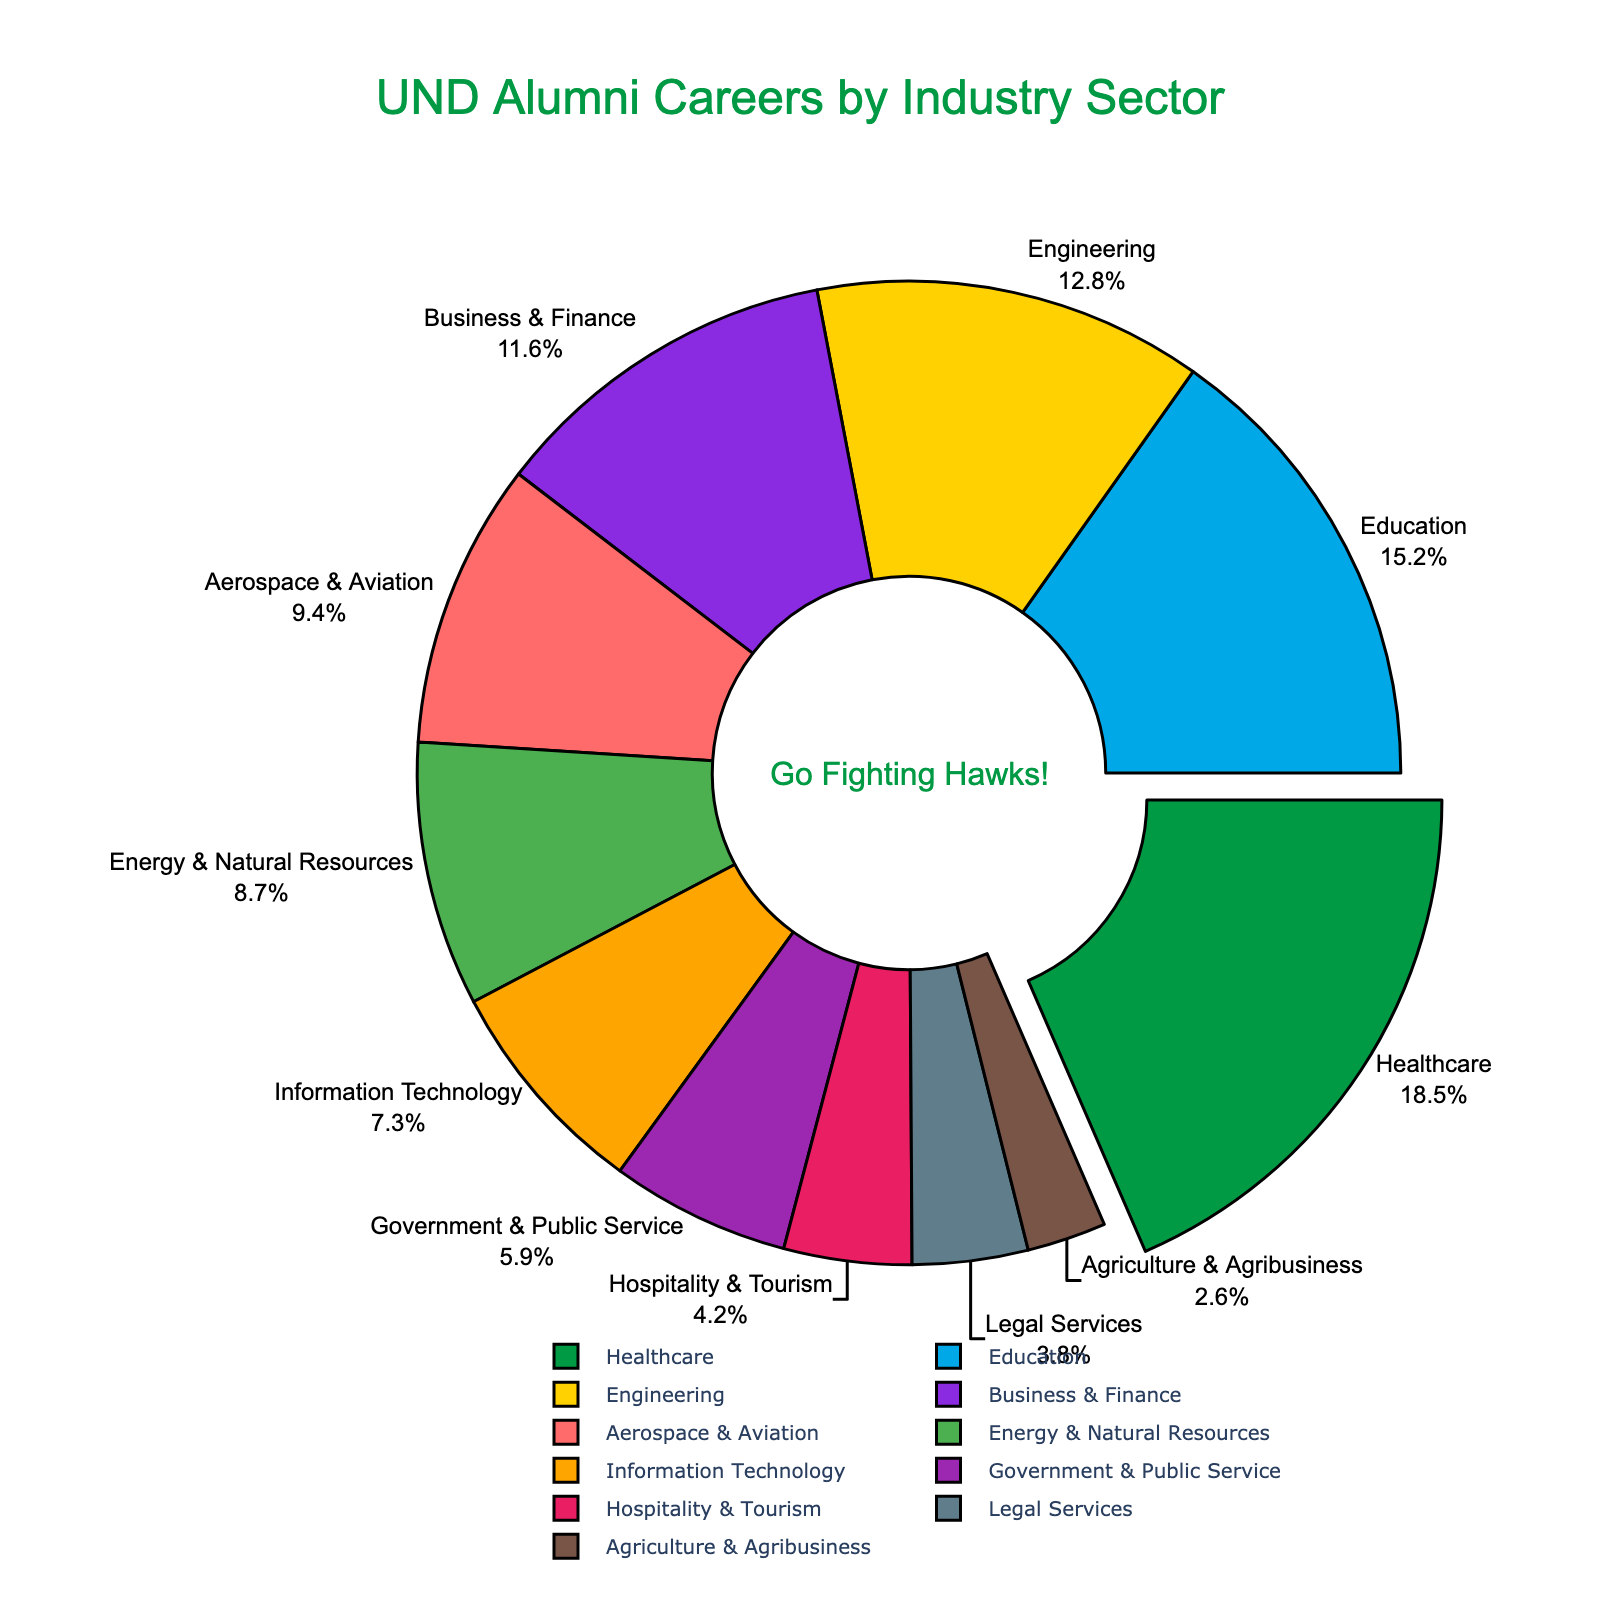What percentage of UND alumni work in the Healthcare sector? The pie chart labels indicate the percentage for each sector. The label for Healthcare shows 18.5%.
Answer: 18.5% Which industry sector employs the smallest percentage of UND alumni? The pie chart shows all sectors with their corresponding percentages. Agriculture & Agribusiness has the smallest percentage, which is 2.6%.
Answer: Agriculture & Agribusiness How many industry sectors have a higher percentage than Business & Finance? To find the number of sectors with a higher percentage than Business & Finance (11.6%), count those sectors: Healthcare (18.5%), Education (15.2%), Engineering (12.8%). Therefore, there are 3 such sectors.
Answer: 3 What is the combined percentage of alumni in Aerospace & Aviation and Information Technology? The slice for Aerospace & Aviation is 9.4% and for Information Technology is 7.3%. Adding these together: 9.4% + 7.3% = 16.7%.
Answer: 16.7% Is the percentage of alumni in Government & Public Service higher or lower than the percentage in Hospitality & Tourism? Refer to the pie chart: Government & Public Service is 5.9%, and Hospitality & Tourism is 4.2%. 5.9% is higher than 4.2%.
Answer: Higher What is the percentage difference between Legal Services and Energy & Natural Resources? Legal Services is 3.8% and Energy & Natural Resources is 8.7%. The difference is 8.7% - 3.8% = 4.9%.
Answer: 4.9% Which industry sector, excluding Healthcare, has the largest percentage? After Healthcare, the largest percentage sector is Education with 15.2%.
Answer: Education If you combined the percentage of alumni in Legal Services, Agriculture & Agribusiness, and Hospitality & Tourism, would it be greater than the percentage in Business & Finance? The percentages are: Legal Services (3.8%), Agriculture & Agribusiness (2.6%), and Hospitality & Tourism (4.2%). Adding these: 3.8% + 2.6% + 4.2% = 10.6%. Business & Finance is 11.6%; hence 10.6% < 11.6%.
Answer: No What are the two sectors with the closest percentages? The slices show Information Technology at 7.3% and Government & Public Service at 5.9%, with a difference of 1.4% which is closer than other gaps between sectors.
Answer: Information Technology and Government & Public Service 